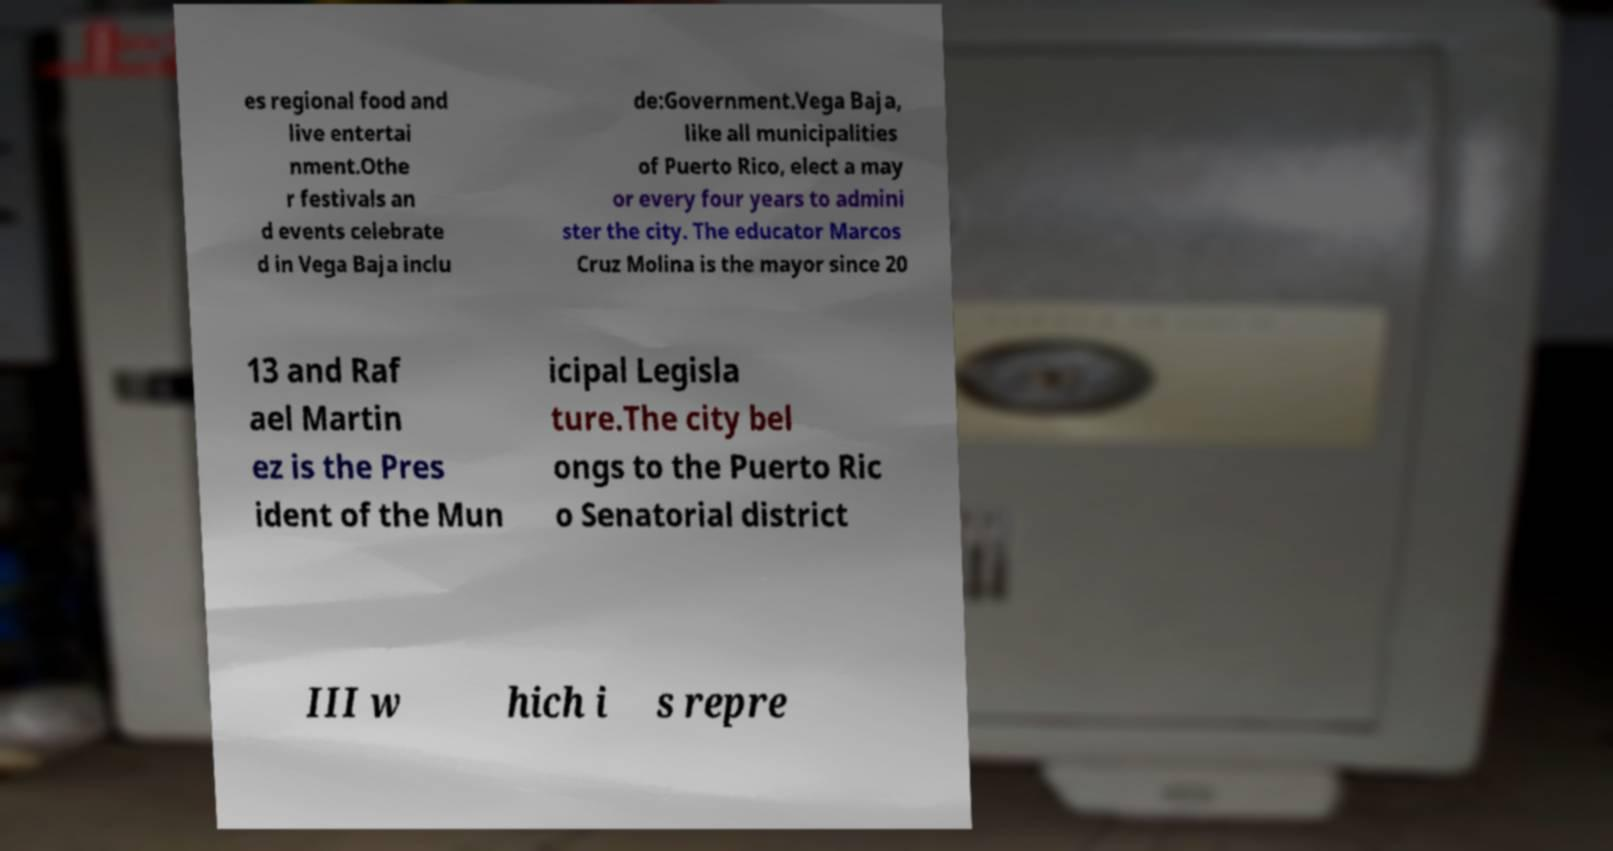Please identify and transcribe the text found in this image. es regional food and live entertai nment.Othe r festivals an d events celebrate d in Vega Baja inclu de:Government.Vega Baja, like all municipalities of Puerto Rico, elect a may or every four years to admini ster the city. The educator Marcos Cruz Molina is the mayor since 20 13 and Raf ael Martin ez is the Pres ident of the Mun icipal Legisla ture.The city bel ongs to the Puerto Ric o Senatorial district III w hich i s repre 